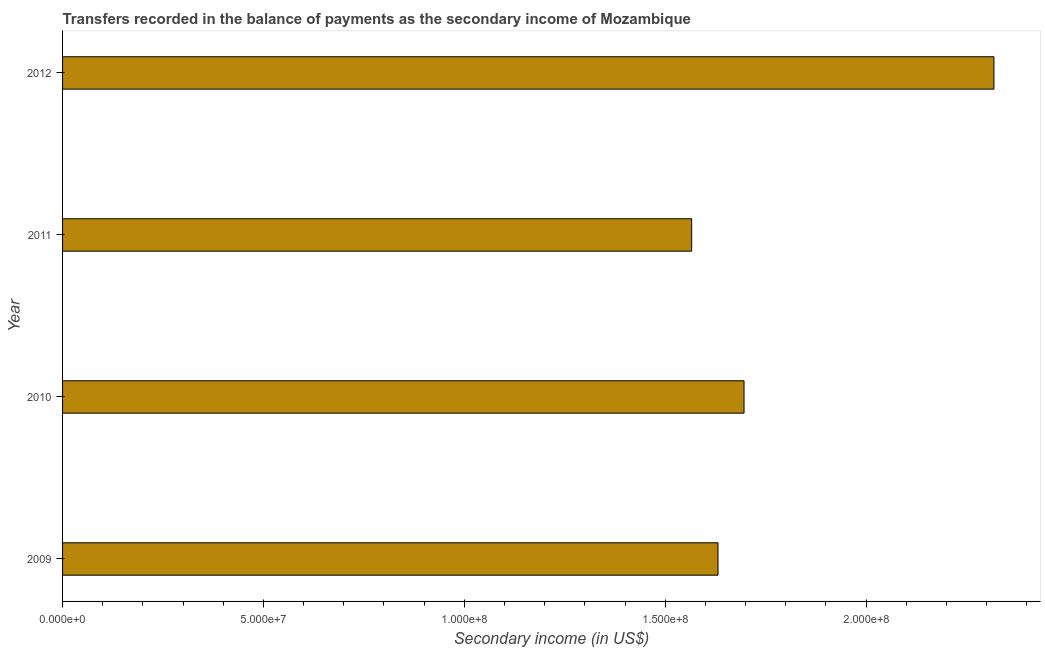Does the graph contain grids?
Offer a very short reply. No. What is the title of the graph?
Provide a succinct answer. Transfers recorded in the balance of payments as the secondary income of Mozambique. What is the label or title of the X-axis?
Keep it short and to the point. Secondary income (in US$). What is the label or title of the Y-axis?
Make the answer very short. Year. What is the amount of secondary income in 2010?
Give a very brief answer. 1.70e+08. Across all years, what is the maximum amount of secondary income?
Provide a succinct answer. 2.32e+08. Across all years, what is the minimum amount of secondary income?
Your response must be concise. 1.57e+08. In which year was the amount of secondary income maximum?
Your response must be concise. 2012. In which year was the amount of secondary income minimum?
Your answer should be very brief. 2011. What is the sum of the amount of secondary income?
Give a very brief answer. 7.21e+08. What is the difference between the amount of secondary income in 2009 and 2010?
Ensure brevity in your answer.  -6.48e+06. What is the average amount of secondary income per year?
Give a very brief answer. 1.80e+08. What is the median amount of secondary income?
Offer a terse response. 1.66e+08. Do a majority of the years between 2011 and 2010 (inclusive) have amount of secondary income greater than 90000000 US$?
Your answer should be very brief. No. What is the ratio of the amount of secondary income in 2009 to that in 2012?
Offer a terse response. 0.7. What is the difference between the highest and the second highest amount of secondary income?
Your answer should be very brief. 6.22e+07. What is the difference between the highest and the lowest amount of secondary income?
Your response must be concise. 7.52e+07. What is the difference between two consecutive major ticks on the X-axis?
Your answer should be compact. 5.00e+07. Are the values on the major ticks of X-axis written in scientific E-notation?
Ensure brevity in your answer.  Yes. What is the Secondary income (in US$) of 2009?
Offer a very short reply. 1.63e+08. What is the Secondary income (in US$) of 2010?
Make the answer very short. 1.70e+08. What is the Secondary income (in US$) in 2011?
Ensure brevity in your answer.  1.57e+08. What is the Secondary income (in US$) in 2012?
Offer a terse response. 2.32e+08. What is the difference between the Secondary income (in US$) in 2009 and 2010?
Give a very brief answer. -6.48e+06. What is the difference between the Secondary income (in US$) in 2009 and 2011?
Offer a very short reply. 6.56e+06. What is the difference between the Secondary income (in US$) in 2009 and 2012?
Provide a succinct answer. -6.87e+07. What is the difference between the Secondary income (in US$) in 2010 and 2011?
Provide a short and direct response. 1.30e+07. What is the difference between the Secondary income (in US$) in 2010 and 2012?
Provide a succinct answer. -6.22e+07. What is the difference between the Secondary income (in US$) in 2011 and 2012?
Offer a very short reply. -7.52e+07. What is the ratio of the Secondary income (in US$) in 2009 to that in 2011?
Ensure brevity in your answer.  1.04. What is the ratio of the Secondary income (in US$) in 2009 to that in 2012?
Offer a very short reply. 0.7. What is the ratio of the Secondary income (in US$) in 2010 to that in 2011?
Your answer should be compact. 1.08. What is the ratio of the Secondary income (in US$) in 2010 to that in 2012?
Offer a very short reply. 0.73. What is the ratio of the Secondary income (in US$) in 2011 to that in 2012?
Make the answer very short. 0.68. 